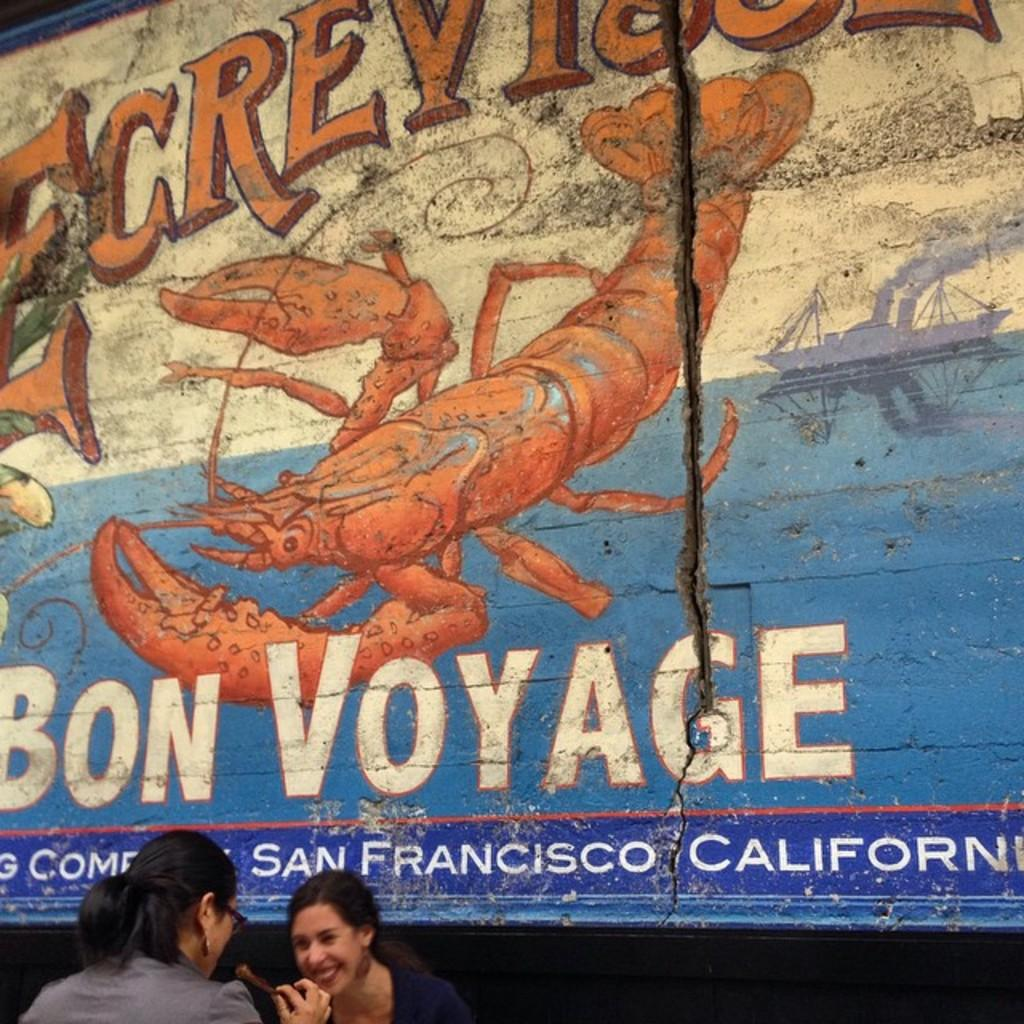Where was the image taken? The image was taken outdoors. Who can be seen in the image? There are two women at the bottom of the image. What is visible in the background of the image? There is a wall with a painting in the background. What else can be seen on the wall in the background? There is text on the wall in the background. What shape is the disease that the women are discussing in the image? There is no indication in the image that the women are discussing a disease, and therefore no shape can be determined. 